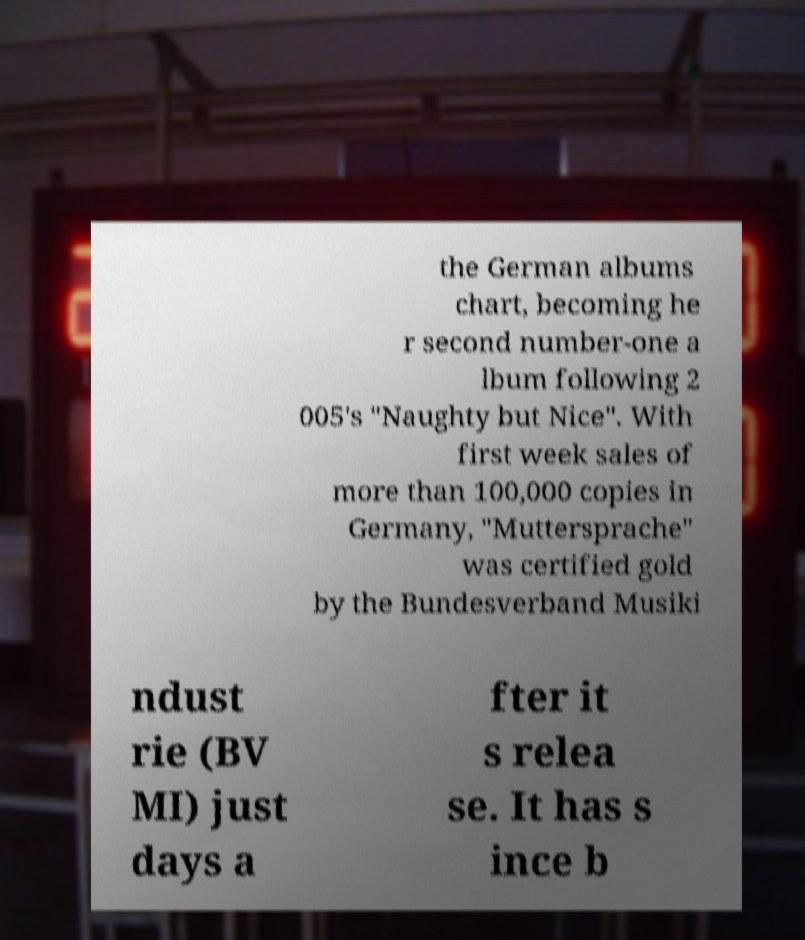Please read and relay the text visible in this image. What does it say? the German albums chart, becoming he r second number-one a lbum following 2 005's "Naughty but Nice". With first week sales of more than 100,000 copies in Germany, "Muttersprache" was certified gold by the Bundesverband Musiki ndust rie (BV MI) just days a fter it s relea se. It has s ince b 